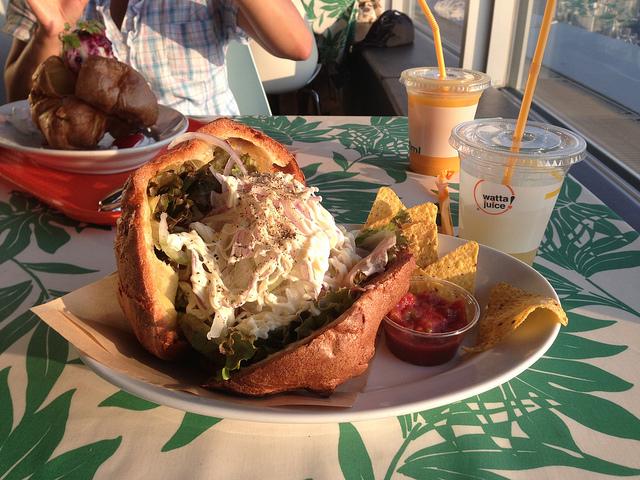What type of sandwich is this?
Keep it brief. Tuna. What is there to dip the chips in?
Quick response, please. Salsa. What kind of drinks are on the table?
Give a very brief answer. Juice. 